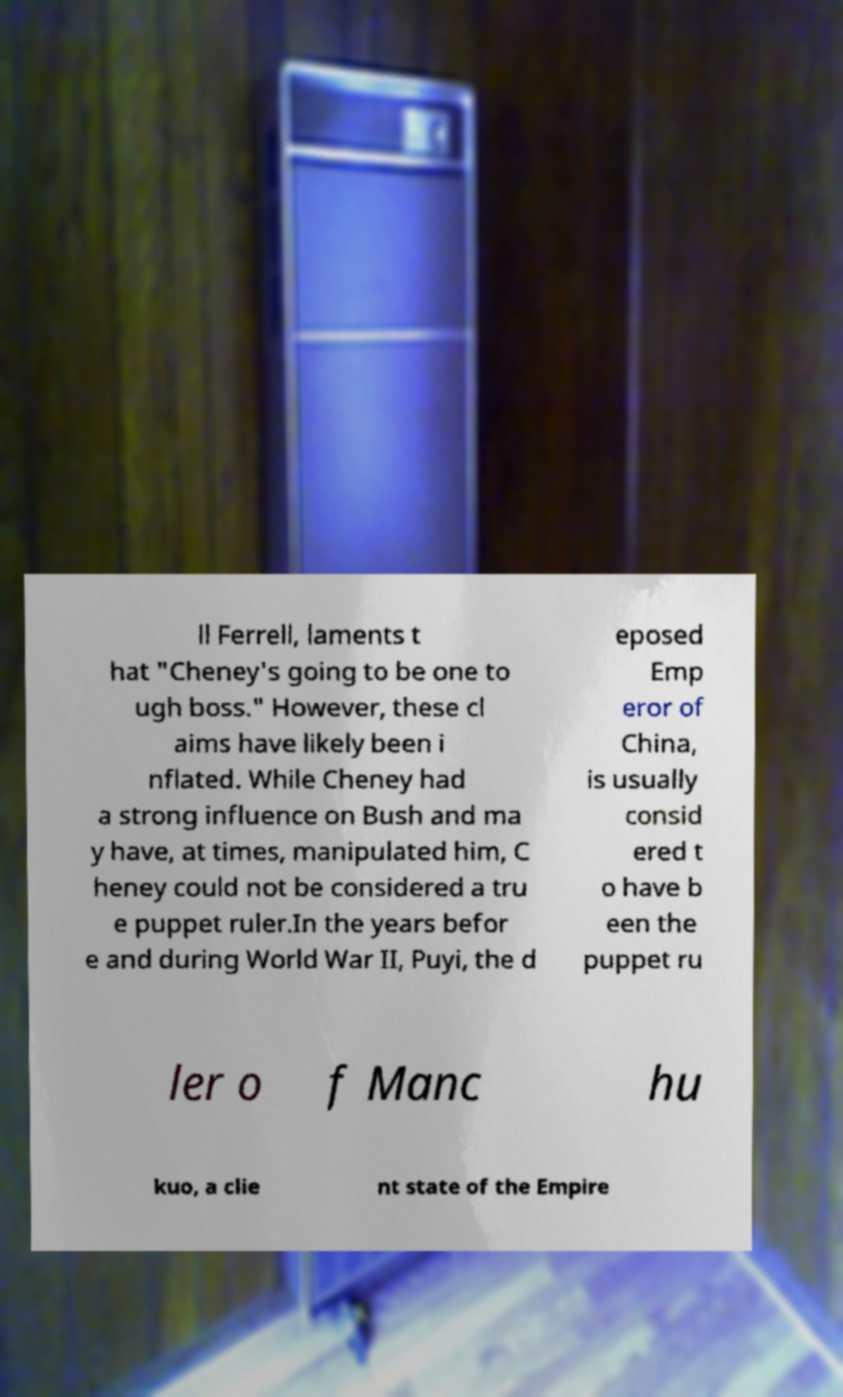I need the written content from this picture converted into text. Can you do that? ll Ferrell, laments t hat "Cheney's going to be one to ugh boss." However, these cl aims have likely been i nflated. While Cheney had a strong influence on Bush and ma y have, at times, manipulated him, C heney could not be considered a tru e puppet ruler.In the years befor e and during World War II, Puyi, the d eposed Emp eror of China, is usually consid ered t o have b een the puppet ru ler o f Manc hu kuo, a clie nt state of the Empire 